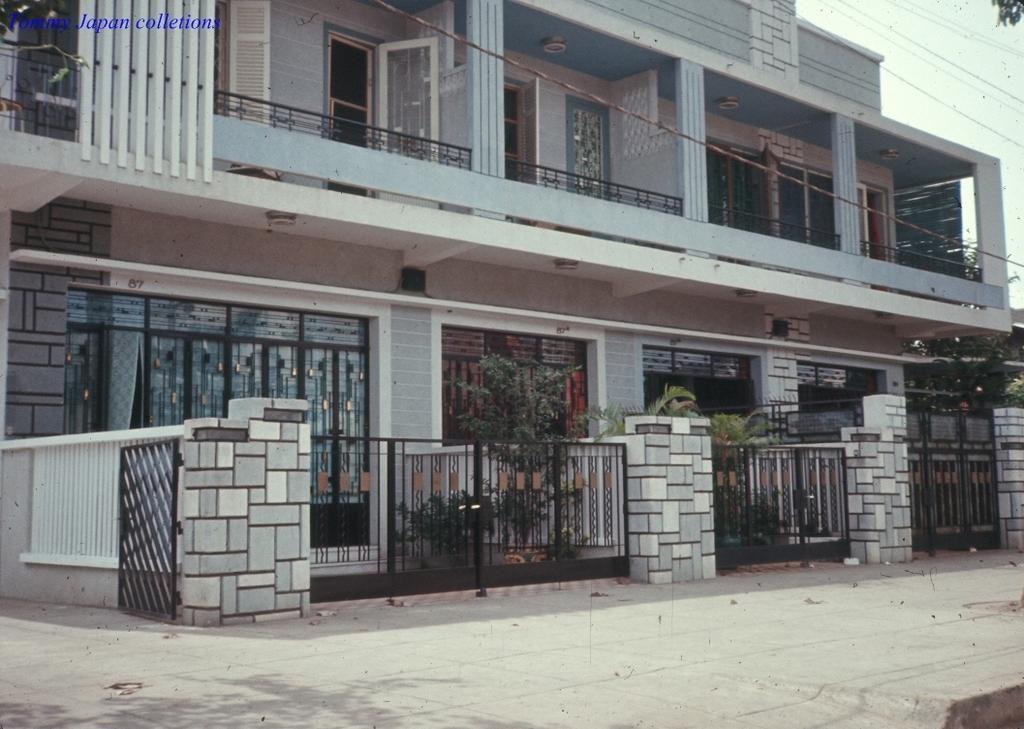What type of structures can be seen in the image? There are buildings in the image. What architectural features are present in the image? There are gates and windows in the image. What type of vegetation is visible in the image? There are plants in the image. What other objects can be seen in the image? There are cables in the image. What part of the natural environment is visible in the image? The sky is visible in the image. What is the chance of the yard being expanded in the image? There is no mention of a yard in the image, so it is not possible to determine the chance of its expansion. 